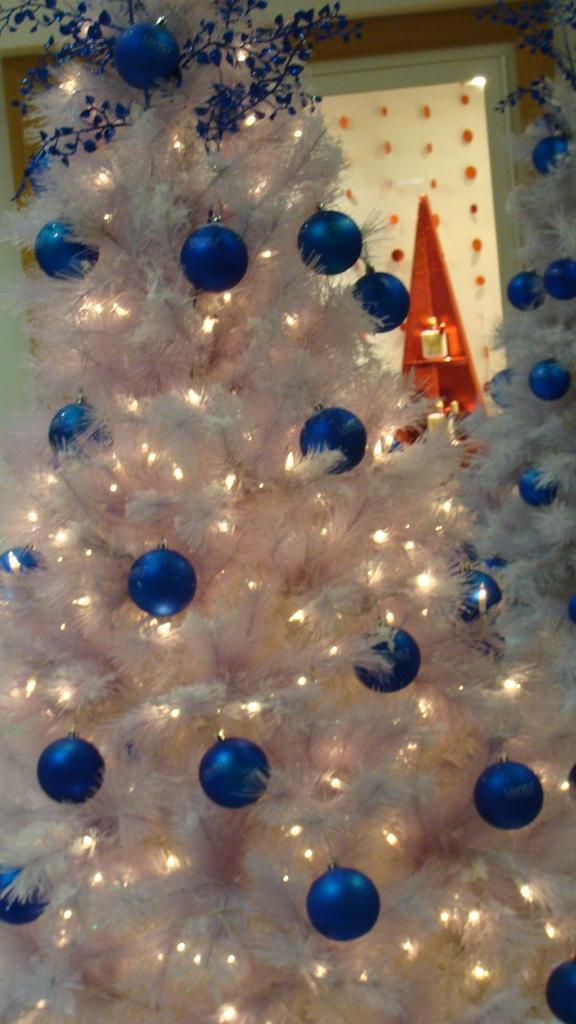How many Christmas trees are in the image? There are two Christmas trees in the image. What decorations can be seen on the Christmas trees? The Christmas trees are decorated with balls and lights. What is visible on the backside of the image? There is an object visible on the backside of the image. What type of decorations are hanging from the door in the image? There are hangings from a door in the image. What type of decorations are hanging from the wall in the image? There are hangings from a wall in the image. How many bears are sitting on the Christmas trees in the image? There are no bears present in the image; the Christmas trees are decorated with balls and lights. 